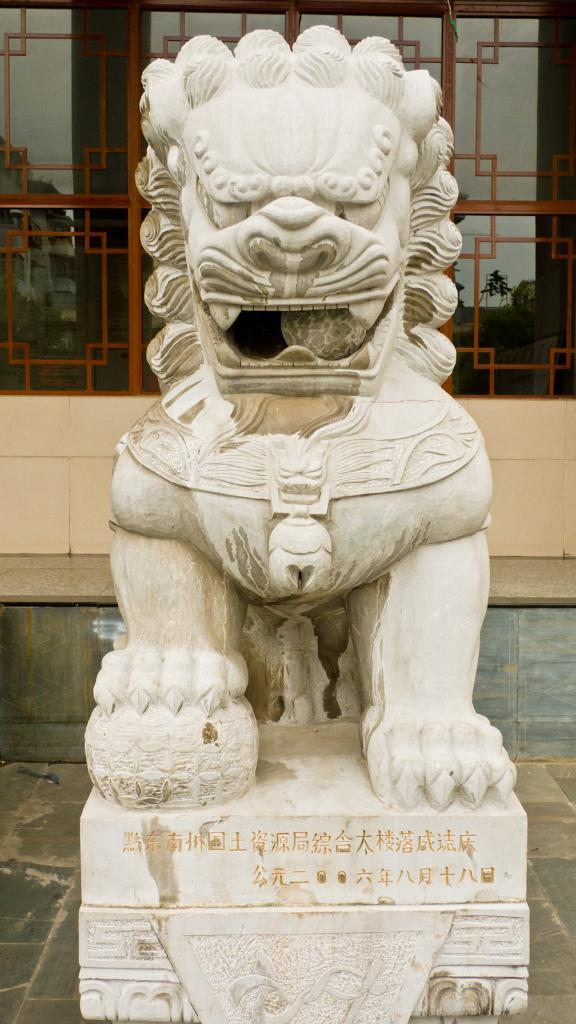What is the main subject in the image? There is a statue in the image. Where is the statue located in the image? The statue is at the bottom of the image. What can be seen in the background of the image? There is a glass wall in the background of the image. What type of truck is visible driving past the statue in the image? There is no truck present in the image; it only features a statue and a glass wall in the background. 